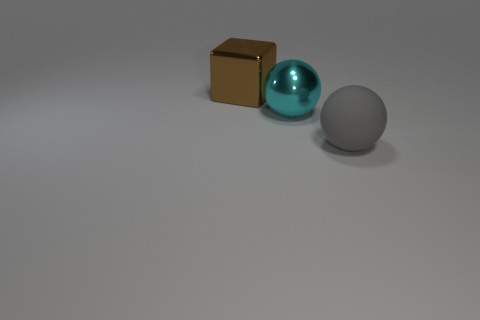Does the gray thing have the same material as the cyan sphere?
Ensure brevity in your answer.  No. There is a thing that is on the right side of the large metallic block and left of the rubber sphere; what color is it?
Your answer should be very brief. Cyan. Is there a gray matte thing of the same size as the cyan thing?
Ensure brevity in your answer.  Yes. What is the size of the object that is in front of the shiny thing that is to the right of the brown shiny cube?
Provide a succinct answer. Large. Are there fewer gray spheres left of the large cyan ball than gray shiny cubes?
Provide a short and direct response. No. Is the big matte sphere the same color as the big block?
Your answer should be very brief. No. The cyan metal ball is what size?
Provide a short and direct response. Large. How many large metal balls have the same color as the large metallic block?
Your answer should be compact. 0. There is a brown metal block on the left side of the big ball behind the large gray matte ball; are there any big brown shiny objects that are in front of it?
Keep it short and to the point. No. There is a gray matte object that is the same size as the cyan metallic ball; what shape is it?
Offer a very short reply. Sphere. 